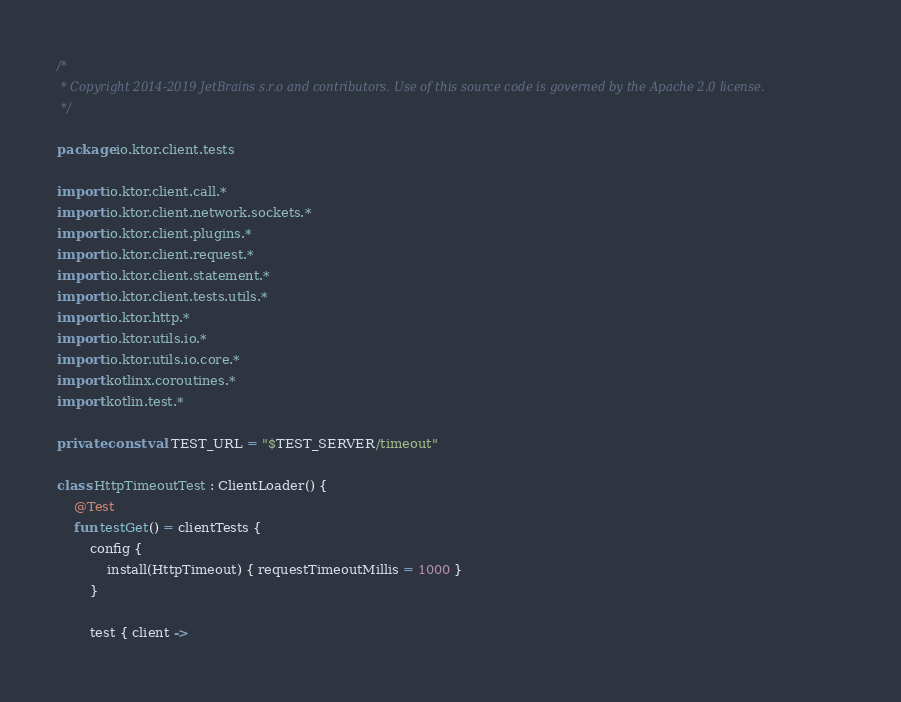<code> <loc_0><loc_0><loc_500><loc_500><_Kotlin_>/*
 * Copyright 2014-2019 JetBrains s.r.o and contributors. Use of this source code is governed by the Apache 2.0 license.
 */

package io.ktor.client.tests

import io.ktor.client.call.*
import io.ktor.client.network.sockets.*
import io.ktor.client.plugins.*
import io.ktor.client.request.*
import io.ktor.client.statement.*
import io.ktor.client.tests.utils.*
import io.ktor.http.*
import io.ktor.utils.io.*
import io.ktor.utils.io.core.*
import kotlinx.coroutines.*
import kotlin.test.*

private const val TEST_URL = "$TEST_SERVER/timeout"

class HttpTimeoutTest : ClientLoader() {
    @Test
    fun testGet() = clientTests {
        config {
            install(HttpTimeout) { requestTimeoutMillis = 1000 }
        }

        test { client -></code> 